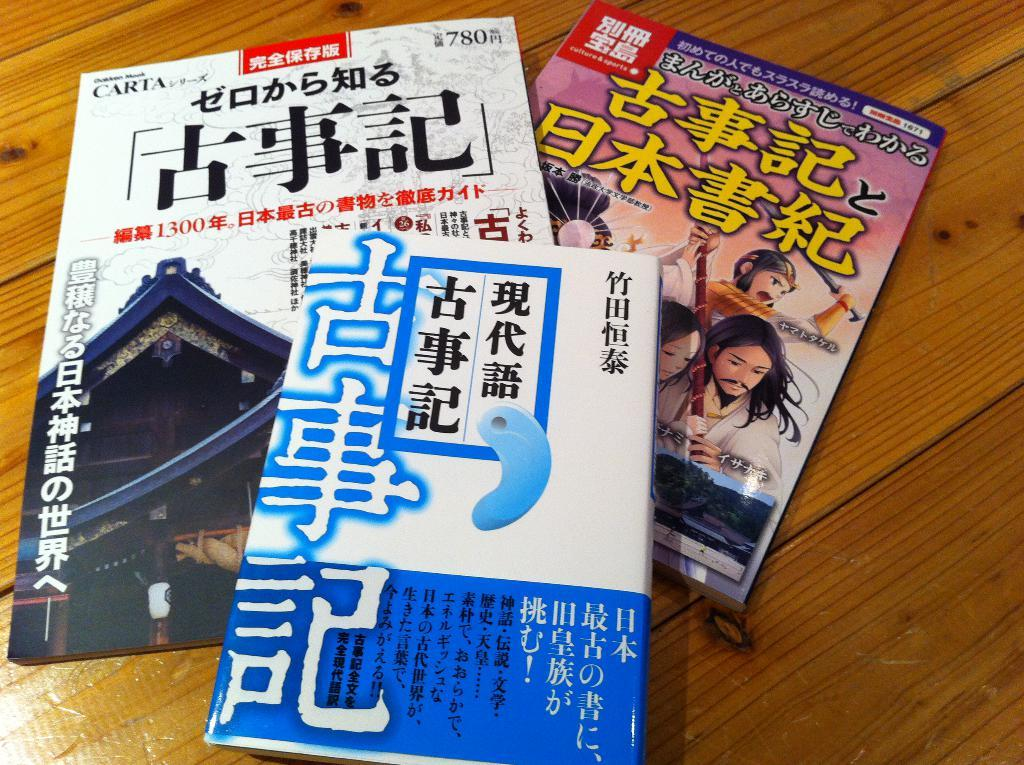<image>
Share a concise interpretation of the image provided. A book with a picture of a temple roof sells for 780, and lies with two other books on a table. 